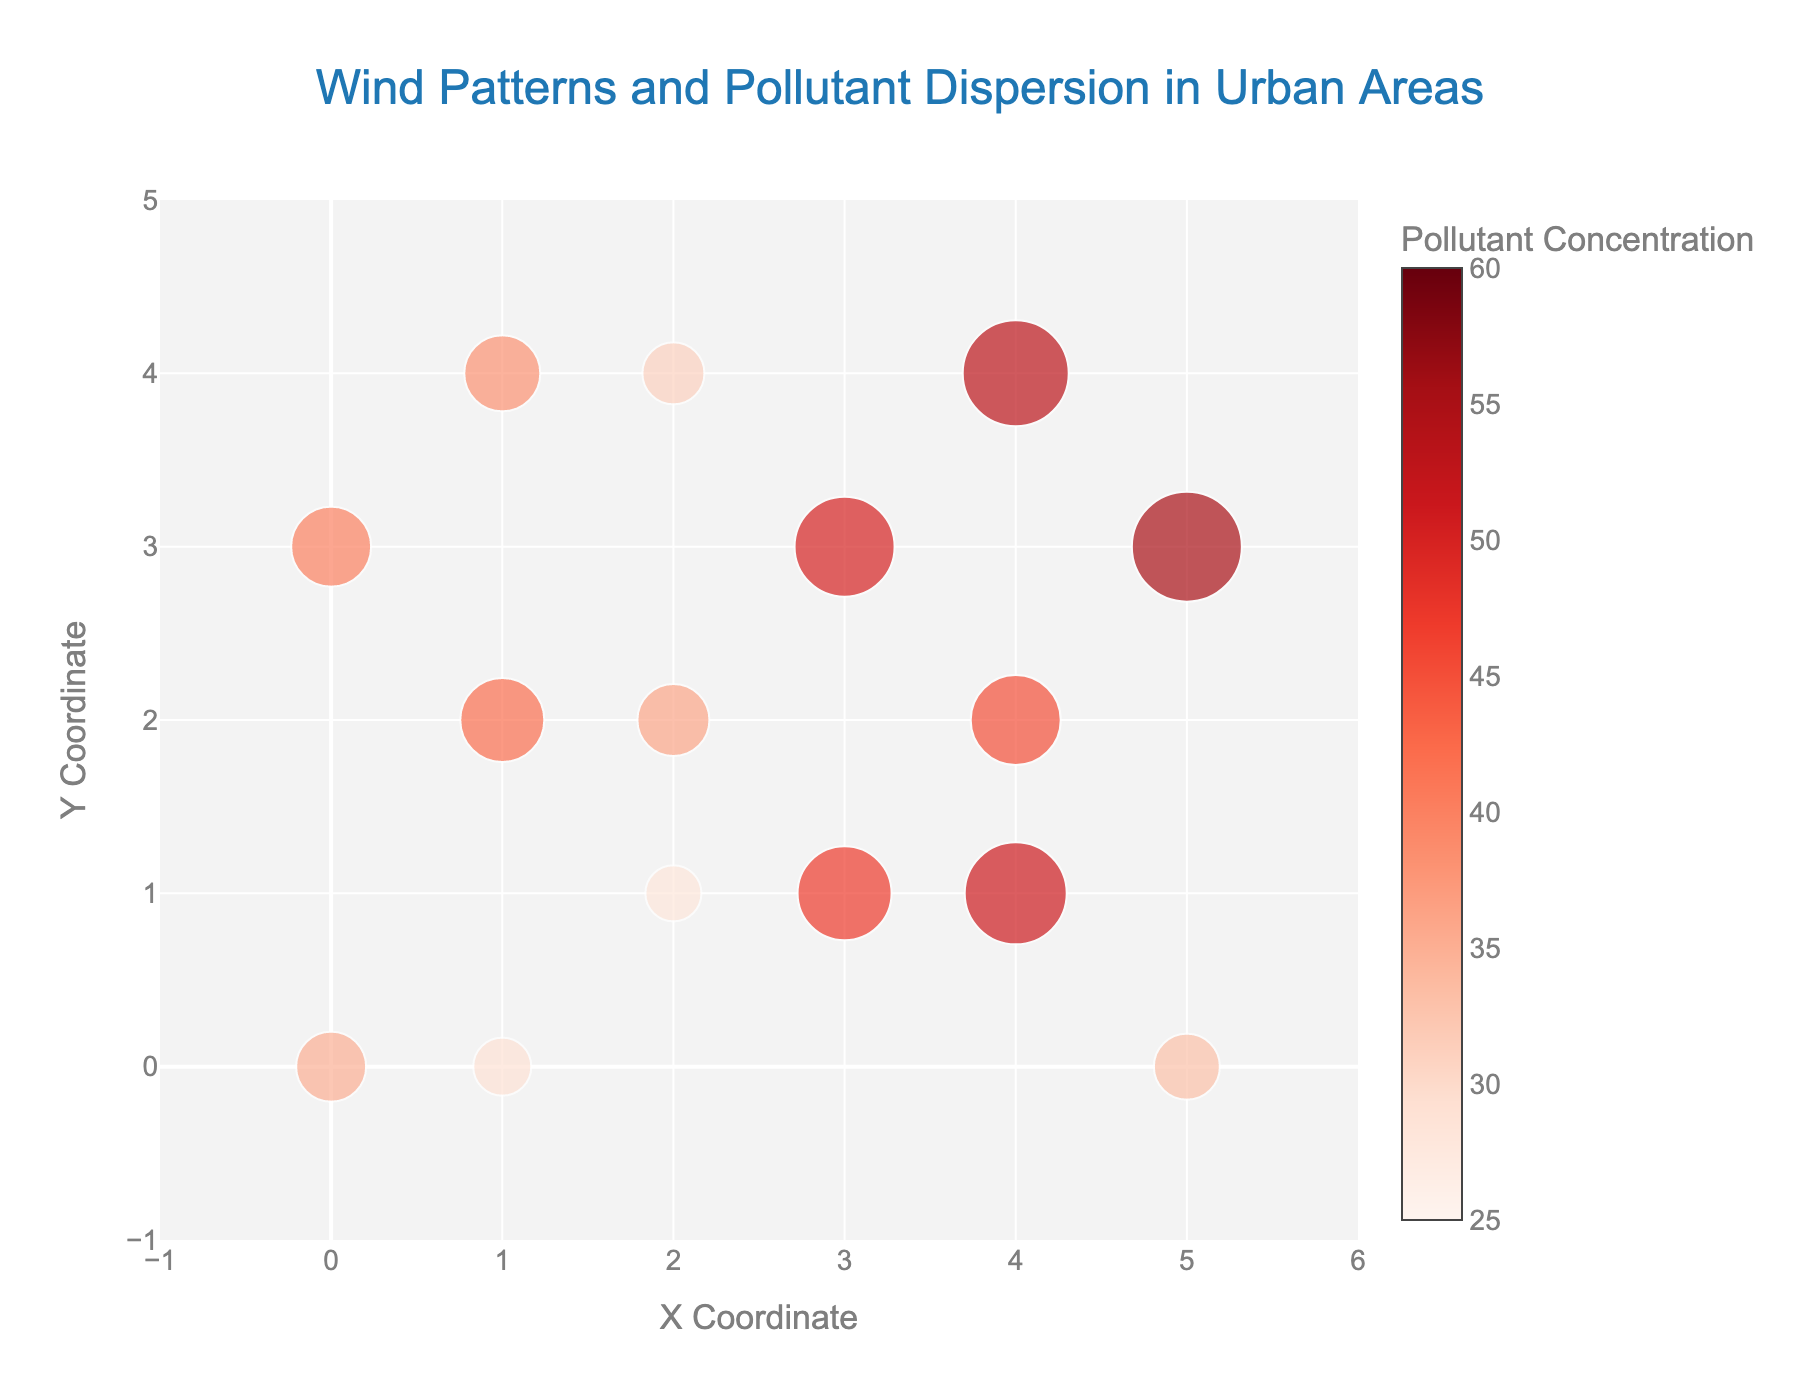What's the title of the figure? The title of the figure can be found at the top center of the plot. It's generally formatted in a larger or bolder font to stand out. In this figure, the title is "Wind Patterns and Pollutant Dispersion in Urban Areas."
Answer: Wind Patterns and Pollutant Dispersion in Urban Areas What are the x and y coordinate ranges displayed on the axes? The range of the x and y coordinates can usually be determined from the axis labels and ticks visible on the plot. In this figure, the x-axis ranges from -1 to 6, and the y-axis ranges from -1 to 5.
Answer: x: [-1, 6], y: [-1, 5] How many data points are shown in the plot? To find the number of data points, count the number of arrows (for wind vectors) or markers (for pollutant concentrations) on the figure. Both elements are based on the same data points. From the dataset, there are 15 points.
Answer: 15 Which data point shows the highest pollutant concentration and what is its value? The color of each marker on the scatter plot indicates pollutant concentration. The legend also helps in determining the exact values. By analyzing the colors and sizes, the point with the highest concentration is the one at (5, 3) with a concentration of 55.
Answer: (5, 3), 55 Which direction do the wind vectors mostly point in the region with the highest pollutant concentration? To determine this, look at the direction of the arrows around the highest pollutant concentration (55) at point (5, 3). The arrow at this point indicates a southeast direction (negative x and y components).
Answer: Southeast What is the pollutant concentration at the data point (3, 1)? Locate the point at coordinates (3, 1) and check its marker size and color against the legend. This point has a pollutant concentration of 47.
Answer: 47 Comparing the points at (1, 0) and (2, 1), which one has a higher pollutant concentration and by how much? Locate the two points on the plot. The pollutant concentration at (1, 0) is 29, and at (2, 1) it is 28. Subtract the smaller concentration from the larger one, 29 - 28.
Answer: (1, 0) by 1 Considering the data points with the same x-coordinate (4), which one has the highest and which one has the lowest pollutant concentration? Identify all points with x=4. The points are (4, 2), (4, 4), and (4, 1) with concentrations of 45, 53, and 51, respectively. The highest is 53 at (4, 4) and the lowest is 45 at (4, 2).
Answer: Highest: (4, 4), Lowest: (4, 2) How does the wind speed vector at (1, 2) compare to the vector at (3, 3)? Compare the lengths of the arrows which represent wind speeds. The vector at (1, 2) has components (-1.8, 3.1), and at (3, 3) it has (-2.1, -1.5). The magnitudes are √((-1.8)² + 3.1²) = 3.6 for (1, 2) and √((-2.1)² + (-1.5)²) = 2.6 for (3, 3).
Answer: (1, 2) has a greater magnitude Which zones of the plot indicate a potential maximum spread of pollutants based on wind patterns and pollutant concentrations? Look for areas with high pollutant concentrations coupled with higher wind speeds or favorable wind directions. Zones with complex wind directions might not disperse pollutants well. The point (5, 3) has high concentration and significant wind vectors possibly influencing dispersion.
Answer: Around (5, 3) 